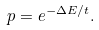Convert formula to latex. <formula><loc_0><loc_0><loc_500><loc_500>p = e ^ { - \Delta E / t } .</formula> 